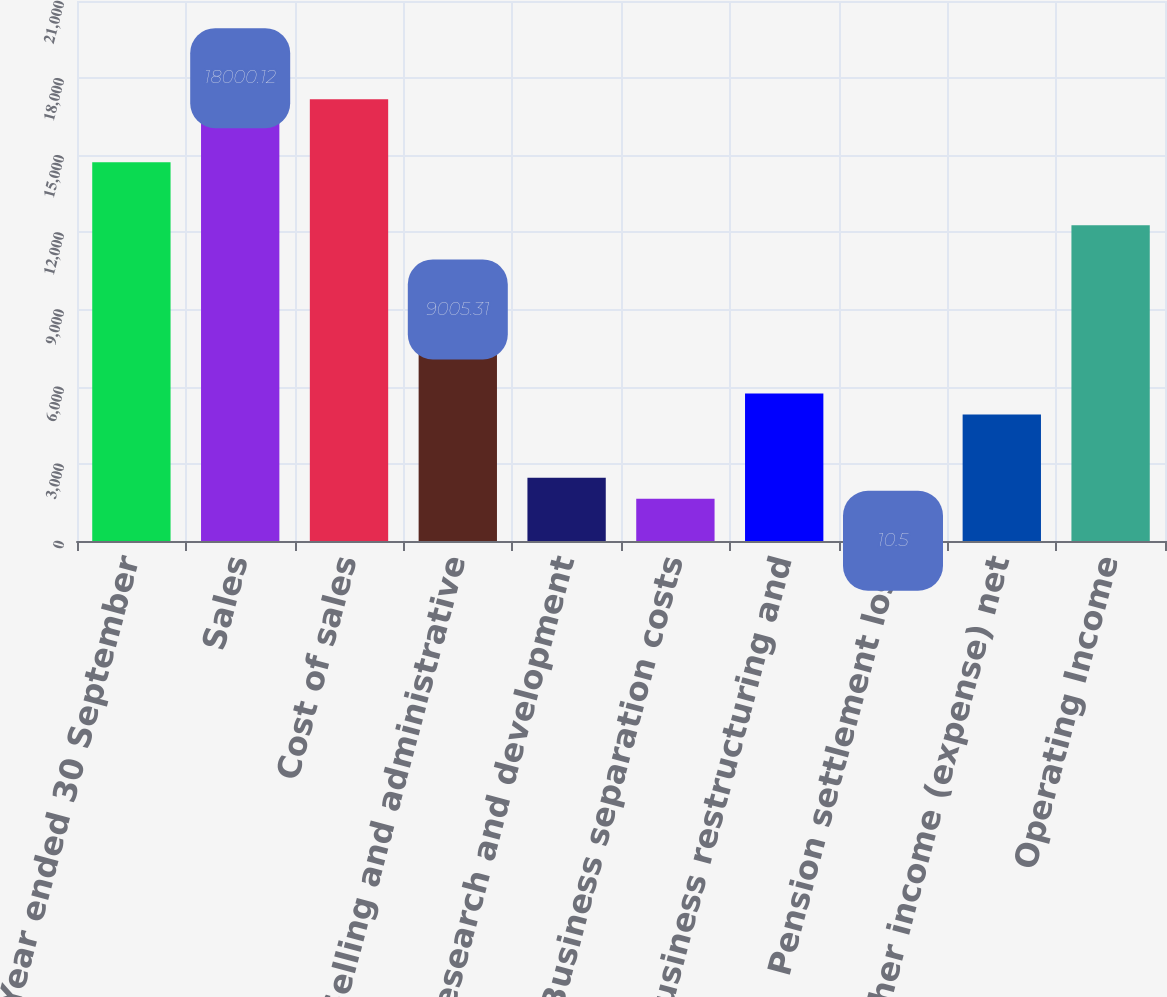<chart> <loc_0><loc_0><loc_500><loc_500><bar_chart><fcel>Year ended 30 September<fcel>Sales<fcel>Cost of sales<fcel>Selling and administrative<fcel>Research and development<fcel>Business separation costs<fcel>Business restructuring and<fcel>Pension settlement loss<fcel>Other income (expense) net<fcel>Operating Income<nl><fcel>14729.3<fcel>18000.1<fcel>17182.4<fcel>9005.31<fcel>2463.63<fcel>1645.92<fcel>5734.47<fcel>10.5<fcel>4916.76<fcel>12276.1<nl></chart> 